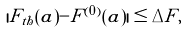Convert formula to latex. <formula><loc_0><loc_0><loc_500><loc_500>| F _ { t h } ( a ) - F ^ { ( 0 ) } ( a ) | \leq \Delta F ,</formula> 